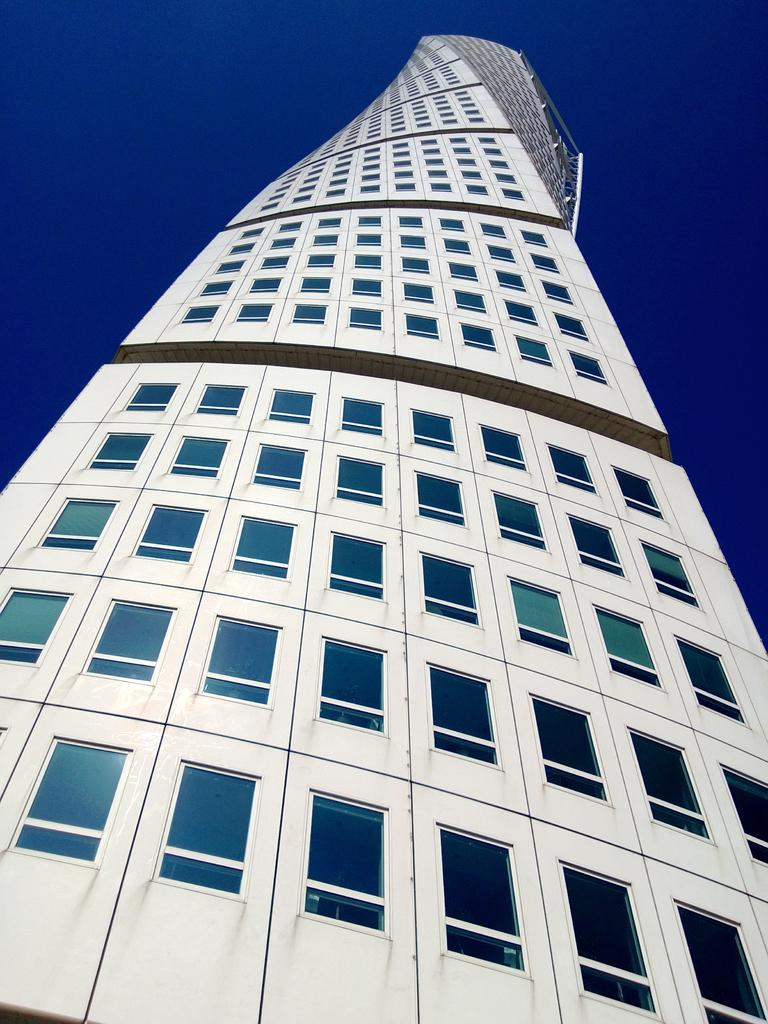What is the color of the building in the image? The building in the image is white. What architectural feature can be seen on the building? The building has multiple windows. What color is present in the background of the image? There is a blue color in the background of the image. How many chairs are placed inside the building in the image? There is no information about chairs or their placement inside the building in the image. 